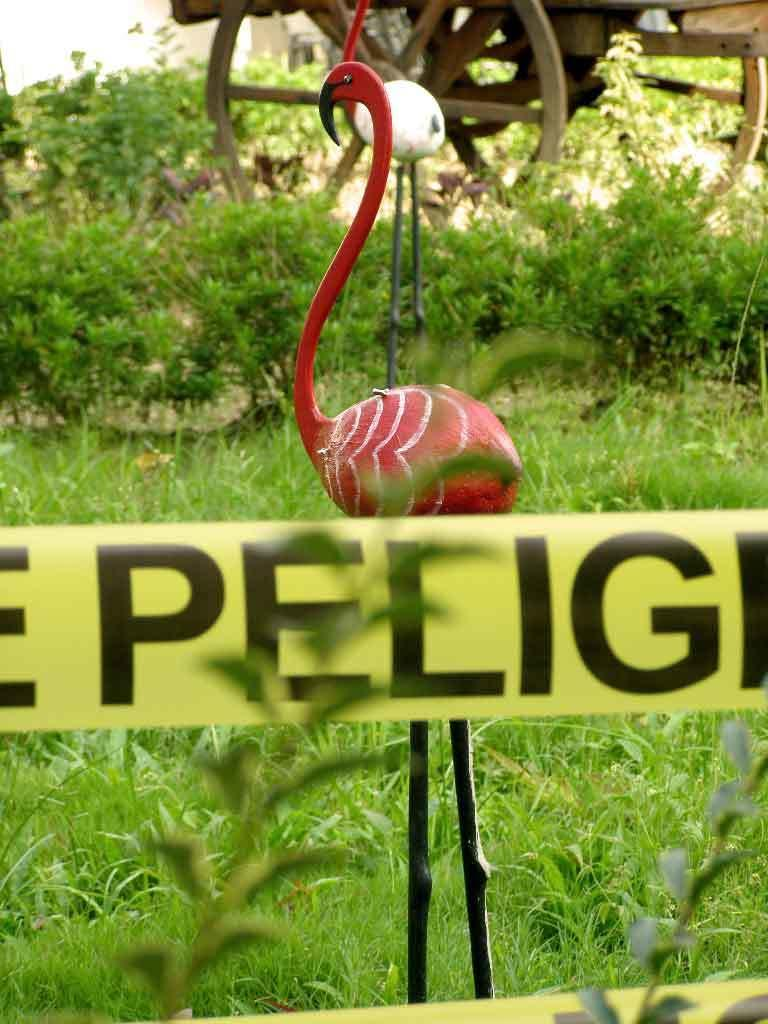What type of vegetation is present in the image? There is grass and plants in the image. What color is the banner visible in the image? There is a small yellow color banner in the image. What objects are on the ground in the image? There are two wooden birds on the ground in the image. What part of a vehicle can be seen in the image? There are two wheels of a vehicle in the image. What type of structure can be seen on the hill in the image? There is no hill or structure present in the image. How many corks are visible in the image? There are no corks present in the image. 